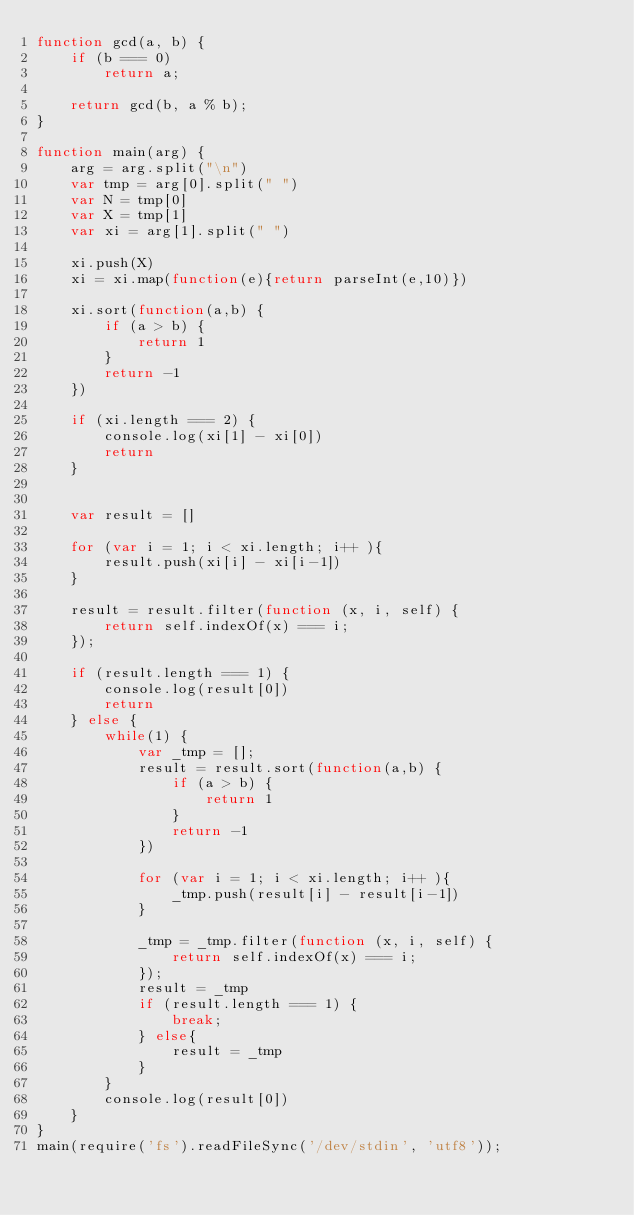<code> <loc_0><loc_0><loc_500><loc_500><_JavaScript_>function gcd(a, b) {
    if (b === 0)
        return a;

    return gcd(b, a % b);
}

function main(arg) {
    arg = arg.split("\n")
    var tmp = arg[0].split(" ")
    var N = tmp[0]
    var X = tmp[1]
    var xi = arg[1].split(" ")
    
    xi.push(X)
    xi = xi.map(function(e){return parseInt(e,10)})
    
    xi.sort(function(a,b) {
        if (a > b) {
            return 1
        }
        return -1
    })
    
    if (xi.length === 2) {
        console.log(xi[1] - xi[0])
        return
    }
    
    
    var result = []
    
    for (var i = 1; i < xi.length; i++ ){
        result.push(xi[i] - xi[i-1])
    }
    
    result = result.filter(function (x, i, self) {
        return self.indexOf(x) === i;
    });
    
    if (result.length === 1) {
        console.log(result[0])
        return
    } else {
        while(1) {
            var _tmp = [];
            result = result.sort(function(a,b) {
                if (a > b) {
                    return 1
                }
                return -1
            })

            for (var i = 1; i < xi.length; i++ ){
                _tmp.push(result[i] - result[i-1])
            }

            _tmp = _tmp.filter(function (x, i, self) {
                return self.indexOf(x) === i;
            });
            result = _tmp
            if (result.length === 1) {
                break;
            } else{
                result = _tmp
            }
        }
        console.log(result[0])
    }
}
main(require('fs').readFileSync('/dev/stdin', 'utf8'));
</code> 